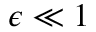<formula> <loc_0><loc_0><loc_500><loc_500>\epsilon \ll 1</formula> 